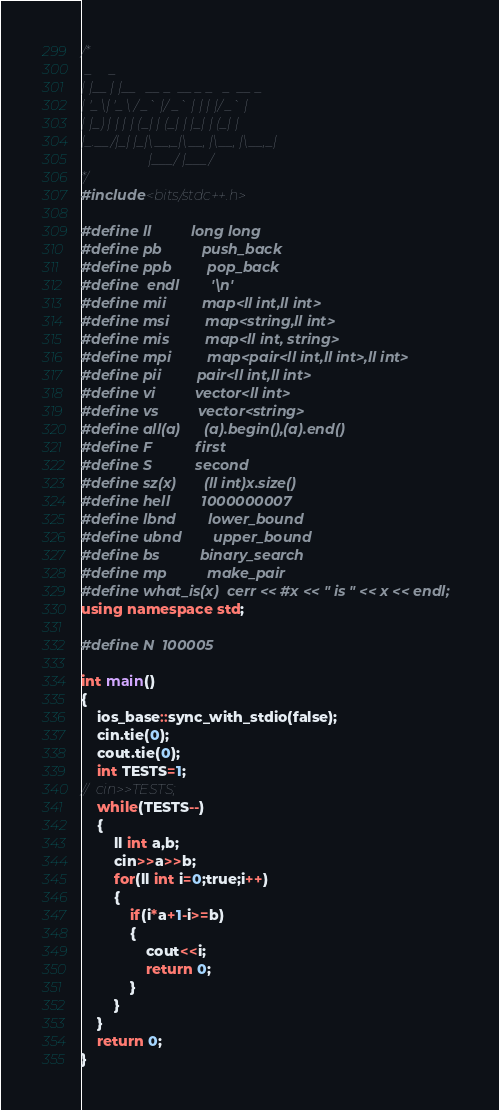Convert code to text. <code><loc_0><loc_0><loc_500><loc_500><_C++_>/*
 _     _                             
| |__ | |__   __ _  __ _ _   _  __ _ 
| '_ \| '_ \ / _` |/ _` | | | |/ _` |
| |_) | | | | (_| | (_| | |_| | (_| |
|_.__/|_| |_|\__,_|\__, |\__, |\__,_|
                   |___/ |___/       
*/
#include<bits/stdc++.h>
 
#define ll          long long
#define pb          push_back
#define ppb         pop_back
#define	endl		'\n'
#define mii         map<ll int,ll int>
#define msi         map<string,ll int>
#define mis         map<ll int, string>
#define mpi         map<pair<ll int,ll int>,ll int>
#define pii         pair<ll int,ll int>
#define vi          vector<ll int>
#define vs          vector<string>
#define all(a)      (a).begin(),(a).end()
#define F           first
#define S           second
#define sz(x)       (ll int)x.size()
#define hell        1000000007
#define lbnd        lower_bound
#define ubnd        upper_bound
#define bs          binary_search
#define mp          make_pair
#define what_is(x)  cerr << #x << " is " << x << endl;
using namespace std;
 
#define N  100005

int main()
{
	ios_base::sync_with_stdio(false);
	cin.tie(0);
	cout.tie(0);
	int TESTS=1;
//	cin>>TESTS;
	while(TESTS--)
	{
		ll int a,b;
		cin>>a>>b;
		for(ll int i=0;true;i++)
		{
			if(i*a+1-i>=b) 
			{
				cout<<i;
				return 0;
			}
		}
	}
	return 0;
}</code> 